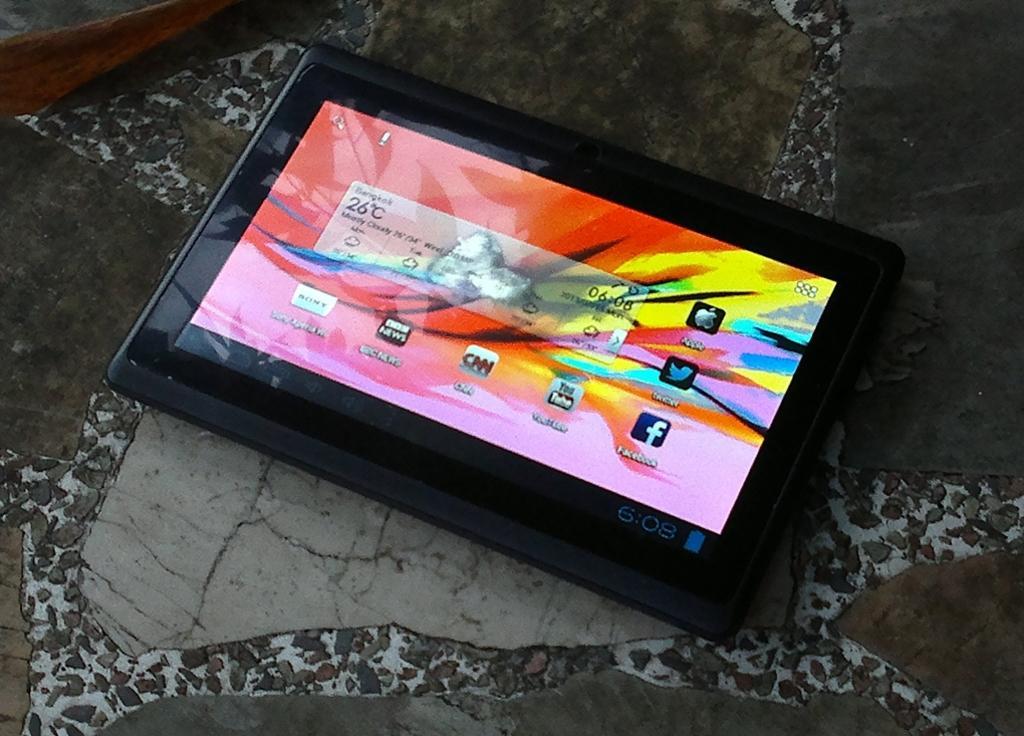Could you give a brief overview of what you see in this image? In this picture we can see a device There is a glass object and a screen is visible on this device. We can see some text, numbers, logos and other things are visible on this screen. This device is visible on the ground. 